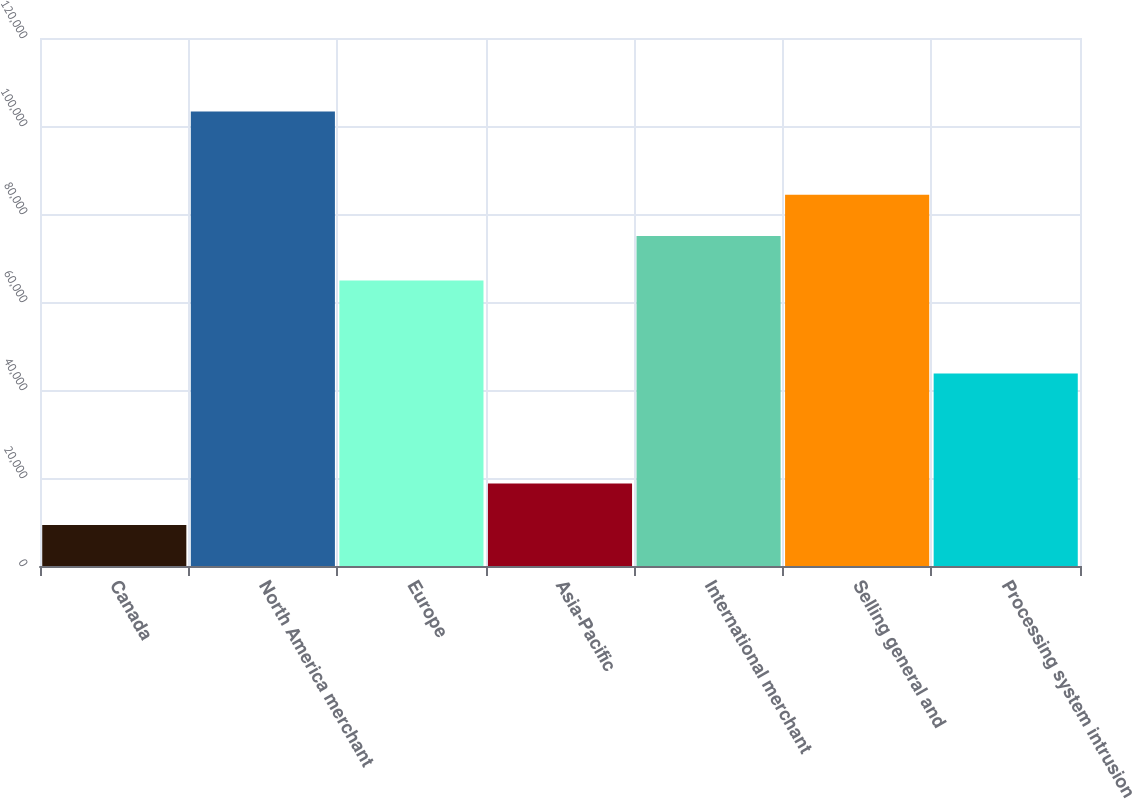Convert chart. <chart><loc_0><loc_0><loc_500><loc_500><bar_chart><fcel>Canada<fcel>North America merchant<fcel>Europe<fcel>Asia-Pacific<fcel>International merchant<fcel>Selling general and<fcel>Processing system intrusion<nl><fcel>9333<fcel>103317<fcel>64870<fcel>18731.4<fcel>74996<fcel>84394.4<fcel>43775<nl></chart> 